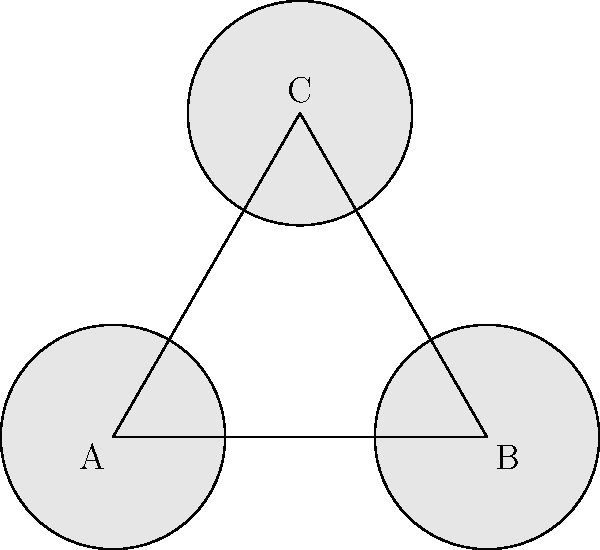In a Welsh textile factory from the late 19th century, three identical spinning machines are arranged in an equilateral triangle formation as shown in the diagram. What is the order of the symmetry group for this arrangement? To determine the order of the symmetry group for this arrangement, we need to consider all the symmetry operations that leave the configuration unchanged:

1. Rotational symmetry:
   - 120° clockwise rotation (R₁)
   - 240° clockwise rotation (R₂)
   - 360° rotation (identity operation, E)

2. Reflection symmetry:
   - Reflection across the line bisecting angle A (S₁)
   - Reflection across the line bisecting angle B (S₂)
   - Reflection across the line bisecting angle C (S₃)

These symmetry operations form a group because:
a) They are closed under composition
b) The identity element (E) exists
c) Each operation has an inverse
d) The operations are associative

The total number of distinct symmetry operations is 6:
{E, R₁, R₂, S₁, S₂, S₃}

Therefore, the order of the symmetry group is 6.

This group is isomorphic to $D_3$, the dihedral group of order 6, which is the symmetry group of an equilateral triangle.
Answer: 6 